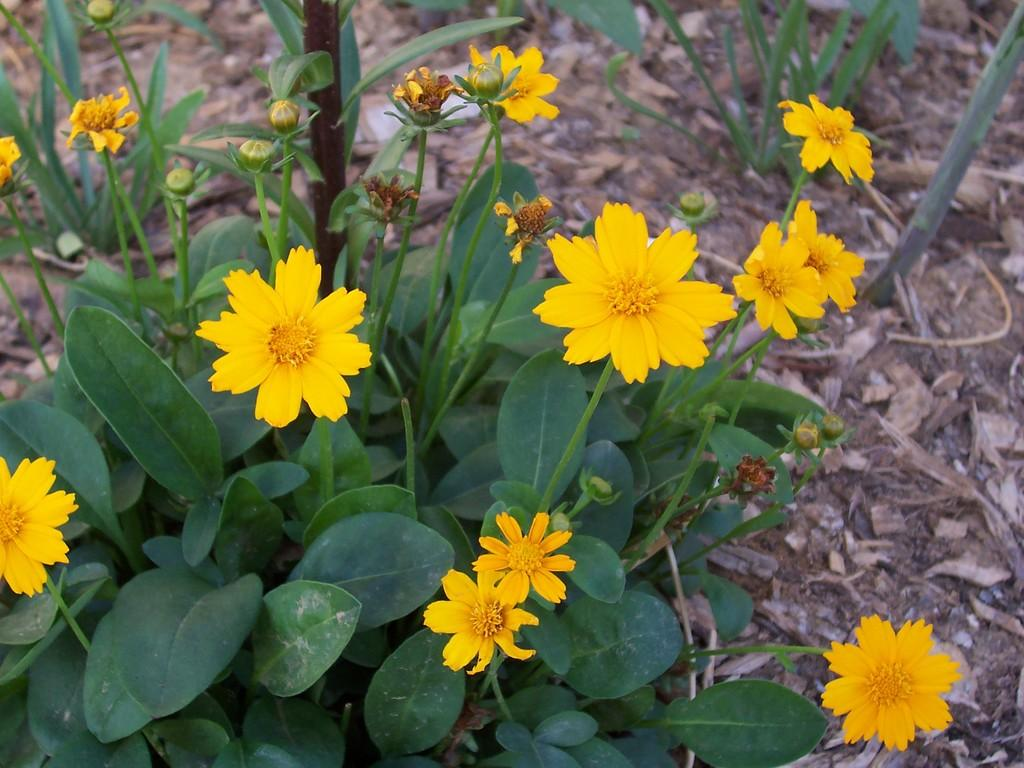What color are the flowers in the image? The flowers in the image are yellow. What other parts of the flowers can be seen besides the petals? The flowers have leaves and stems. What else is present on the land in the image? Dry leaves are present on the land in the image. Can you tell me how many times the flowers coil around each other in the image? There is no indication in the image that the flowers are coiling around each other. 